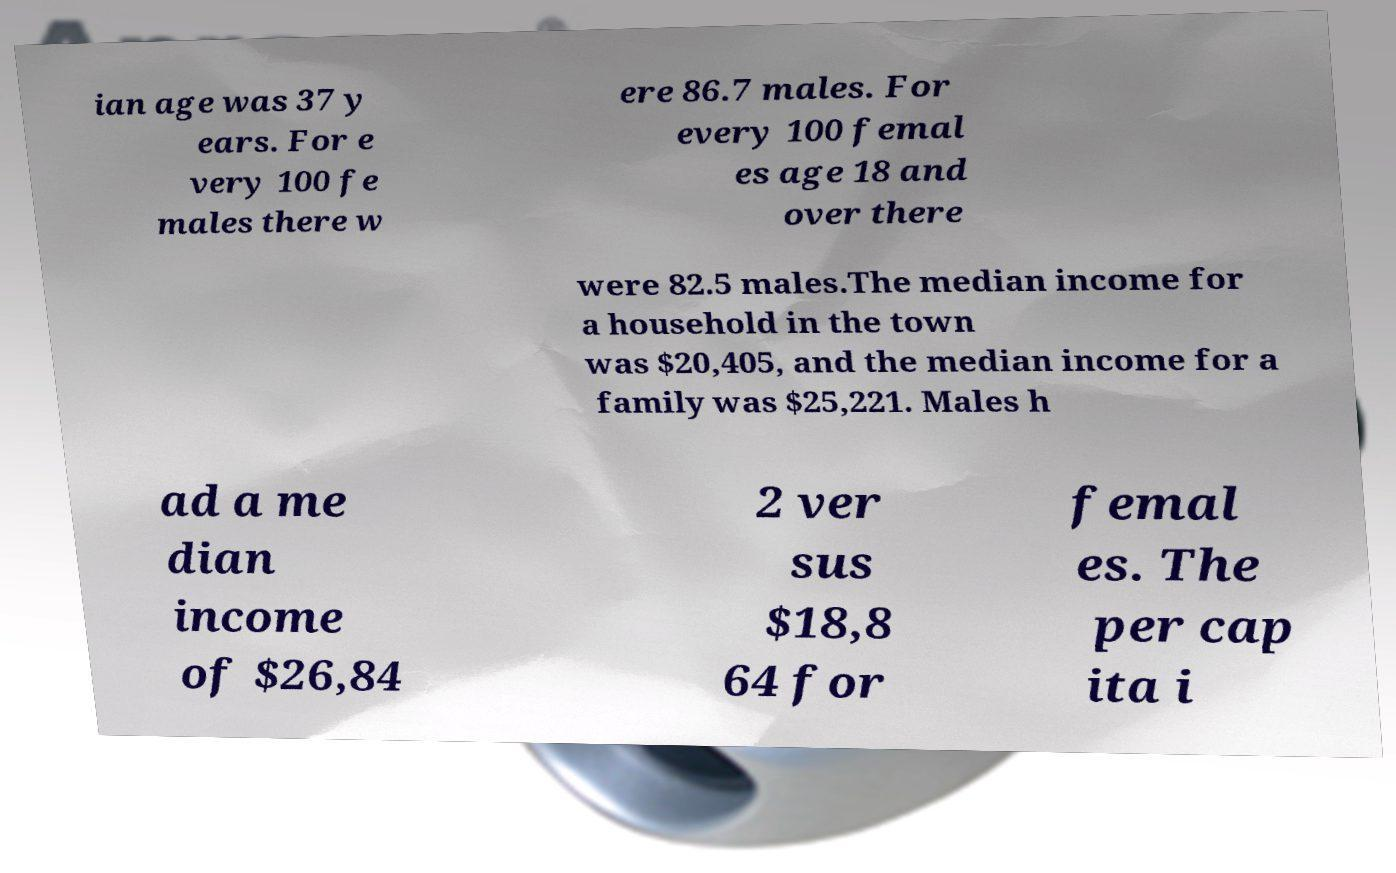Can you accurately transcribe the text from the provided image for me? ian age was 37 y ears. For e very 100 fe males there w ere 86.7 males. For every 100 femal es age 18 and over there were 82.5 males.The median income for a household in the town was $20,405, and the median income for a family was $25,221. Males h ad a me dian income of $26,84 2 ver sus $18,8 64 for femal es. The per cap ita i 